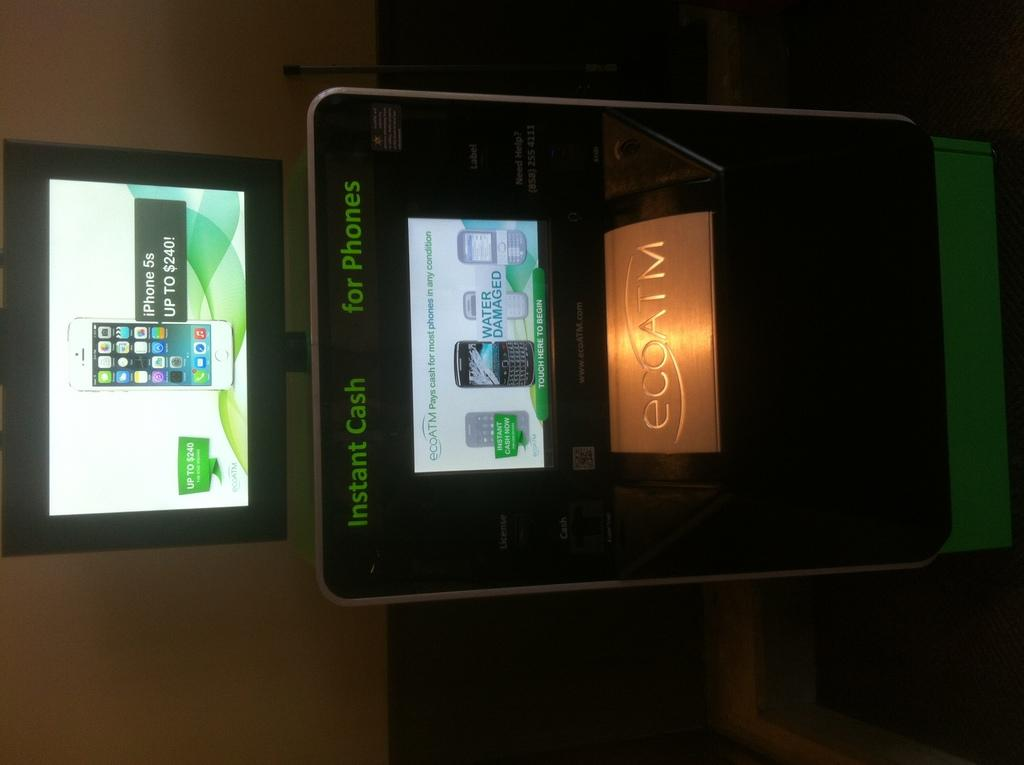<image>
Create a compact narrative representing the image presented. A machine displays glowing green lettering that indicates it provides instant cash for phones. 